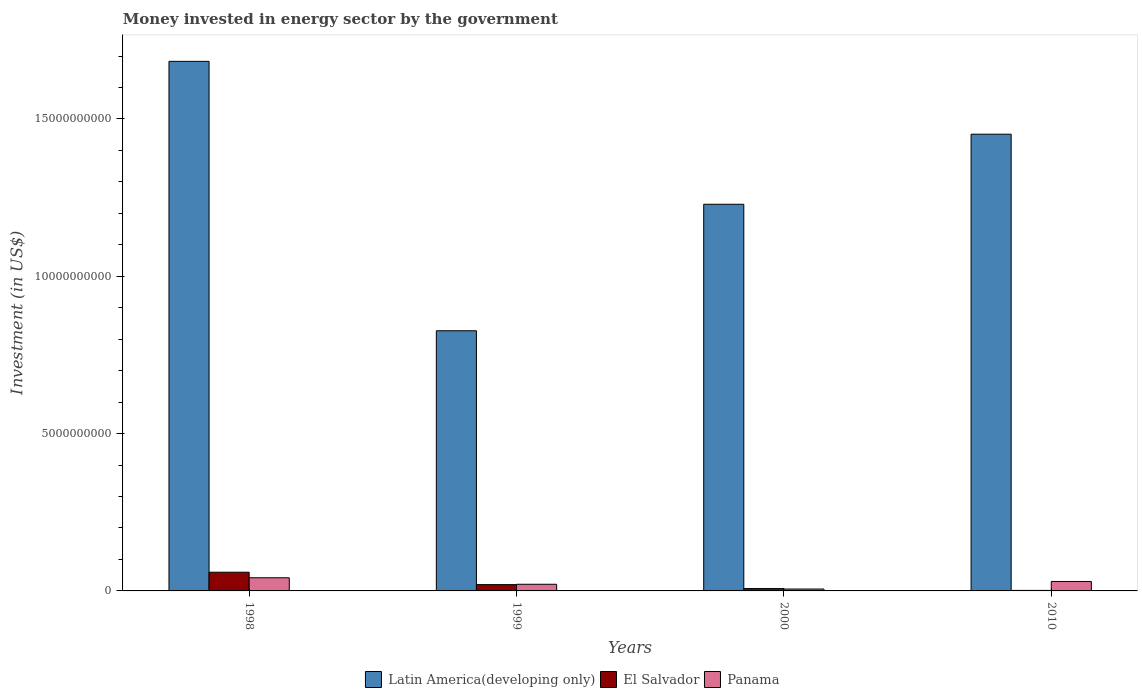How many different coloured bars are there?
Your answer should be compact. 3. How many groups of bars are there?
Your response must be concise. 4. How many bars are there on the 1st tick from the left?
Keep it short and to the point. 3. In how many cases, is the number of bars for a given year not equal to the number of legend labels?
Offer a very short reply. 0. What is the money spent in energy sector in Latin America(developing only) in 1999?
Give a very brief answer. 8.27e+09. Across all years, what is the maximum money spent in energy sector in Panama?
Ensure brevity in your answer.  4.18e+08. Across all years, what is the minimum money spent in energy sector in Latin America(developing only)?
Provide a succinct answer. 8.27e+09. In which year was the money spent in energy sector in Panama maximum?
Keep it short and to the point. 1998. In which year was the money spent in energy sector in Latin America(developing only) minimum?
Give a very brief answer. 1999. What is the total money spent in energy sector in Panama in the graph?
Give a very brief answer. 9.89e+08. What is the difference between the money spent in energy sector in Panama in 1998 and that in 1999?
Ensure brevity in your answer.  2.07e+08. What is the difference between the money spent in energy sector in El Salvador in 1998 and the money spent in energy sector in Latin America(developing only) in 1999?
Offer a very short reply. -7.67e+09. What is the average money spent in energy sector in Latin America(developing only) per year?
Make the answer very short. 1.30e+1. In the year 2010, what is the difference between the money spent in energy sector in Latin America(developing only) and money spent in energy sector in Panama?
Offer a very short reply. 1.42e+1. What is the ratio of the money spent in energy sector in Panama in 1998 to that in 1999?
Your answer should be compact. 1.98. What is the difference between the highest and the second highest money spent in energy sector in Latin America(developing only)?
Give a very brief answer. 2.31e+09. What is the difference between the highest and the lowest money spent in energy sector in Latin America(developing only)?
Offer a very short reply. 8.56e+09. Is the sum of the money spent in energy sector in El Salvador in 1999 and 2010 greater than the maximum money spent in energy sector in Panama across all years?
Make the answer very short. No. What does the 2nd bar from the left in 2000 represents?
Keep it short and to the point. El Salvador. What does the 1st bar from the right in 1998 represents?
Provide a short and direct response. Panama. How many bars are there?
Provide a short and direct response. 12. Are all the bars in the graph horizontal?
Your response must be concise. No. What is the difference between two consecutive major ticks on the Y-axis?
Make the answer very short. 5.00e+09. How are the legend labels stacked?
Offer a very short reply. Horizontal. What is the title of the graph?
Your response must be concise. Money invested in energy sector by the government. Does "East Asia (all income levels)" appear as one of the legend labels in the graph?
Give a very brief answer. No. What is the label or title of the Y-axis?
Your answer should be compact. Investment (in US$). What is the Investment (in US$) in Latin America(developing only) in 1998?
Your response must be concise. 1.68e+1. What is the Investment (in US$) in El Salvador in 1998?
Give a very brief answer. 5.94e+08. What is the Investment (in US$) of Panama in 1998?
Make the answer very short. 4.18e+08. What is the Investment (in US$) of Latin America(developing only) in 1999?
Your answer should be very brief. 8.27e+09. What is the Investment (in US$) in El Salvador in 1999?
Give a very brief answer. 2.00e+08. What is the Investment (in US$) of Panama in 1999?
Your answer should be compact. 2.11e+08. What is the Investment (in US$) in Latin America(developing only) in 2000?
Make the answer very short. 1.23e+1. What is the Investment (in US$) of El Salvador in 2000?
Provide a succinct answer. 7.50e+07. What is the Investment (in US$) of Panama in 2000?
Your answer should be very brief. 5.98e+07. What is the Investment (in US$) of Latin America(developing only) in 2010?
Your response must be concise. 1.45e+1. What is the Investment (in US$) of El Salvador in 2010?
Give a very brief answer. 1.60e+07. What is the Investment (in US$) in Panama in 2010?
Offer a very short reply. 3.00e+08. Across all years, what is the maximum Investment (in US$) in Latin America(developing only)?
Provide a short and direct response. 1.68e+1. Across all years, what is the maximum Investment (in US$) of El Salvador?
Provide a short and direct response. 5.94e+08. Across all years, what is the maximum Investment (in US$) in Panama?
Ensure brevity in your answer.  4.18e+08. Across all years, what is the minimum Investment (in US$) in Latin America(developing only)?
Give a very brief answer. 8.27e+09. Across all years, what is the minimum Investment (in US$) of El Salvador?
Provide a succinct answer. 1.60e+07. Across all years, what is the minimum Investment (in US$) of Panama?
Your answer should be very brief. 5.98e+07. What is the total Investment (in US$) of Latin America(developing only) in the graph?
Make the answer very short. 5.19e+1. What is the total Investment (in US$) in El Salvador in the graph?
Give a very brief answer. 8.85e+08. What is the total Investment (in US$) in Panama in the graph?
Your answer should be very brief. 9.89e+08. What is the difference between the Investment (in US$) of Latin America(developing only) in 1998 and that in 1999?
Offer a very short reply. 8.56e+09. What is the difference between the Investment (in US$) in El Salvador in 1998 and that in 1999?
Offer a very short reply. 3.94e+08. What is the difference between the Investment (in US$) of Panama in 1998 and that in 1999?
Offer a very short reply. 2.07e+08. What is the difference between the Investment (in US$) of Latin America(developing only) in 1998 and that in 2000?
Give a very brief answer. 4.54e+09. What is the difference between the Investment (in US$) of El Salvador in 1998 and that in 2000?
Keep it short and to the point. 5.19e+08. What is the difference between the Investment (in US$) of Panama in 1998 and that in 2000?
Keep it short and to the point. 3.58e+08. What is the difference between the Investment (in US$) in Latin America(developing only) in 1998 and that in 2010?
Your response must be concise. 2.31e+09. What is the difference between the Investment (in US$) in El Salvador in 1998 and that in 2010?
Give a very brief answer. 5.78e+08. What is the difference between the Investment (in US$) of Panama in 1998 and that in 2010?
Offer a very short reply. 1.18e+08. What is the difference between the Investment (in US$) in Latin America(developing only) in 1999 and that in 2000?
Offer a very short reply. -4.02e+09. What is the difference between the Investment (in US$) in El Salvador in 1999 and that in 2000?
Provide a succinct answer. 1.25e+08. What is the difference between the Investment (in US$) in Panama in 1999 and that in 2000?
Your answer should be compact. 1.51e+08. What is the difference between the Investment (in US$) in Latin America(developing only) in 1999 and that in 2010?
Your answer should be very brief. -6.25e+09. What is the difference between the Investment (in US$) of El Salvador in 1999 and that in 2010?
Provide a succinct answer. 1.84e+08. What is the difference between the Investment (in US$) of Panama in 1999 and that in 2010?
Provide a succinct answer. -8.91e+07. What is the difference between the Investment (in US$) of Latin America(developing only) in 2000 and that in 2010?
Your response must be concise. -2.23e+09. What is the difference between the Investment (in US$) of El Salvador in 2000 and that in 2010?
Provide a succinct answer. 5.90e+07. What is the difference between the Investment (in US$) of Panama in 2000 and that in 2010?
Provide a succinct answer. -2.40e+08. What is the difference between the Investment (in US$) of Latin America(developing only) in 1998 and the Investment (in US$) of El Salvador in 1999?
Provide a short and direct response. 1.66e+1. What is the difference between the Investment (in US$) of Latin America(developing only) in 1998 and the Investment (in US$) of Panama in 1999?
Give a very brief answer. 1.66e+1. What is the difference between the Investment (in US$) in El Salvador in 1998 and the Investment (in US$) in Panama in 1999?
Offer a very short reply. 3.83e+08. What is the difference between the Investment (in US$) of Latin America(developing only) in 1998 and the Investment (in US$) of El Salvador in 2000?
Give a very brief answer. 1.68e+1. What is the difference between the Investment (in US$) of Latin America(developing only) in 1998 and the Investment (in US$) of Panama in 2000?
Your response must be concise. 1.68e+1. What is the difference between the Investment (in US$) of El Salvador in 1998 and the Investment (in US$) of Panama in 2000?
Provide a succinct answer. 5.34e+08. What is the difference between the Investment (in US$) in Latin America(developing only) in 1998 and the Investment (in US$) in El Salvador in 2010?
Make the answer very short. 1.68e+1. What is the difference between the Investment (in US$) of Latin America(developing only) in 1998 and the Investment (in US$) of Panama in 2010?
Keep it short and to the point. 1.65e+1. What is the difference between the Investment (in US$) in El Salvador in 1998 and the Investment (in US$) in Panama in 2010?
Your response must be concise. 2.94e+08. What is the difference between the Investment (in US$) of Latin America(developing only) in 1999 and the Investment (in US$) of El Salvador in 2000?
Keep it short and to the point. 8.19e+09. What is the difference between the Investment (in US$) of Latin America(developing only) in 1999 and the Investment (in US$) of Panama in 2000?
Provide a succinct answer. 8.21e+09. What is the difference between the Investment (in US$) in El Salvador in 1999 and the Investment (in US$) in Panama in 2000?
Offer a very short reply. 1.40e+08. What is the difference between the Investment (in US$) in Latin America(developing only) in 1999 and the Investment (in US$) in El Salvador in 2010?
Your response must be concise. 8.25e+09. What is the difference between the Investment (in US$) in Latin America(developing only) in 1999 and the Investment (in US$) in Panama in 2010?
Your answer should be compact. 7.97e+09. What is the difference between the Investment (in US$) of El Salvador in 1999 and the Investment (in US$) of Panama in 2010?
Provide a short and direct response. -1.00e+08. What is the difference between the Investment (in US$) in Latin America(developing only) in 2000 and the Investment (in US$) in El Salvador in 2010?
Give a very brief answer. 1.23e+1. What is the difference between the Investment (in US$) in Latin America(developing only) in 2000 and the Investment (in US$) in Panama in 2010?
Your response must be concise. 1.20e+1. What is the difference between the Investment (in US$) of El Salvador in 2000 and the Investment (in US$) of Panama in 2010?
Ensure brevity in your answer.  -2.25e+08. What is the average Investment (in US$) of Latin America(developing only) per year?
Provide a short and direct response. 1.30e+1. What is the average Investment (in US$) of El Salvador per year?
Your response must be concise. 2.21e+08. What is the average Investment (in US$) in Panama per year?
Ensure brevity in your answer.  2.47e+08. In the year 1998, what is the difference between the Investment (in US$) of Latin America(developing only) and Investment (in US$) of El Salvador?
Offer a terse response. 1.62e+1. In the year 1998, what is the difference between the Investment (in US$) in Latin America(developing only) and Investment (in US$) in Panama?
Give a very brief answer. 1.64e+1. In the year 1998, what is the difference between the Investment (in US$) in El Salvador and Investment (in US$) in Panama?
Provide a succinct answer. 1.76e+08. In the year 1999, what is the difference between the Investment (in US$) in Latin America(developing only) and Investment (in US$) in El Salvador?
Provide a succinct answer. 8.07e+09. In the year 1999, what is the difference between the Investment (in US$) of Latin America(developing only) and Investment (in US$) of Panama?
Provide a short and direct response. 8.06e+09. In the year 1999, what is the difference between the Investment (in US$) in El Salvador and Investment (in US$) in Panama?
Offer a very short reply. -1.10e+07. In the year 2000, what is the difference between the Investment (in US$) in Latin America(developing only) and Investment (in US$) in El Salvador?
Offer a terse response. 1.22e+1. In the year 2000, what is the difference between the Investment (in US$) of Latin America(developing only) and Investment (in US$) of Panama?
Provide a short and direct response. 1.22e+1. In the year 2000, what is the difference between the Investment (in US$) of El Salvador and Investment (in US$) of Panama?
Your response must be concise. 1.52e+07. In the year 2010, what is the difference between the Investment (in US$) in Latin America(developing only) and Investment (in US$) in El Salvador?
Provide a succinct answer. 1.45e+1. In the year 2010, what is the difference between the Investment (in US$) in Latin America(developing only) and Investment (in US$) in Panama?
Make the answer very short. 1.42e+1. In the year 2010, what is the difference between the Investment (in US$) of El Salvador and Investment (in US$) of Panama?
Provide a succinct answer. -2.84e+08. What is the ratio of the Investment (in US$) of Latin America(developing only) in 1998 to that in 1999?
Ensure brevity in your answer.  2.04. What is the ratio of the Investment (in US$) of El Salvador in 1998 to that in 1999?
Offer a very short reply. 2.97. What is the ratio of the Investment (in US$) in Panama in 1998 to that in 1999?
Your answer should be compact. 1.98. What is the ratio of the Investment (in US$) in Latin America(developing only) in 1998 to that in 2000?
Ensure brevity in your answer.  1.37. What is the ratio of the Investment (in US$) of El Salvador in 1998 to that in 2000?
Keep it short and to the point. 7.92. What is the ratio of the Investment (in US$) of Panama in 1998 to that in 2000?
Provide a short and direct response. 6.99. What is the ratio of the Investment (in US$) of Latin America(developing only) in 1998 to that in 2010?
Ensure brevity in your answer.  1.16. What is the ratio of the Investment (in US$) in El Salvador in 1998 to that in 2010?
Provide a succinct answer. 37.12. What is the ratio of the Investment (in US$) of Panama in 1998 to that in 2010?
Make the answer very short. 1.39. What is the ratio of the Investment (in US$) of Latin America(developing only) in 1999 to that in 2000?
Ensure brevity in your answer.  0.67. What is the ratio of the Investment (in US$) in El Salvador in 1999 to that in 2000?
Your response must be concise. 2.67. What is the ratio of the Investment (in US$) of Panama in 1999 to that in 2000?
Provide a succinct answer. 3.53. What is the ratio of the Investment (in US$) of Latin America(developing only) in 1999 to that in 2010?
Offer a very short reply. 0.57. What is the ratio of the Investment (in US$) in El Salvador in 1999 to that in 2010?
Offer a terse response. 12.51. What is the ratio of the Investment (in US$) of Panama in 1999 to that in 2010?
Your response must be concise. 0.7. What is the ratio of the Investment (in US$) in Latin America(developing only) in 2000 to that in 2010?
Make the answer very short. 0.85. What is the ratio of the Investment (in US$) in El Salvador in 2000 to that in 2010?
Ensure brevity in your answer.  4.69. What is the ratio of the Investment (in US$) in Panama in 2000 to that in 2010?
Provide a succinct answer. 0.2. What is the difference between the highest and the second highest Investment (in US$) of Latin America(developing only)?
Ensure brevity in your answer.  2.31e+09. What is the difference between the highest and the second highest Investment (in US$) in El Salvador?
Your response must be concise. 3.94e+08. What is the difference between the highest and the second highest Investment (in US$) in Panama?
Your answer should be very brief. 1.18e+08. What is the difference between the highest and the lowest Investment (in US$) of Latin America(developing only)?
Offer a very short reply. 8.56e+09. What is the difference between the highest and the lowest Investment (in US$) of El Salvador?
Ensure brevity in your answer.  5.78e+08. What is the difference between the highest and the lowest Investment (in US$) of Panama?
Offer a very short reply. 3.58e+08. 